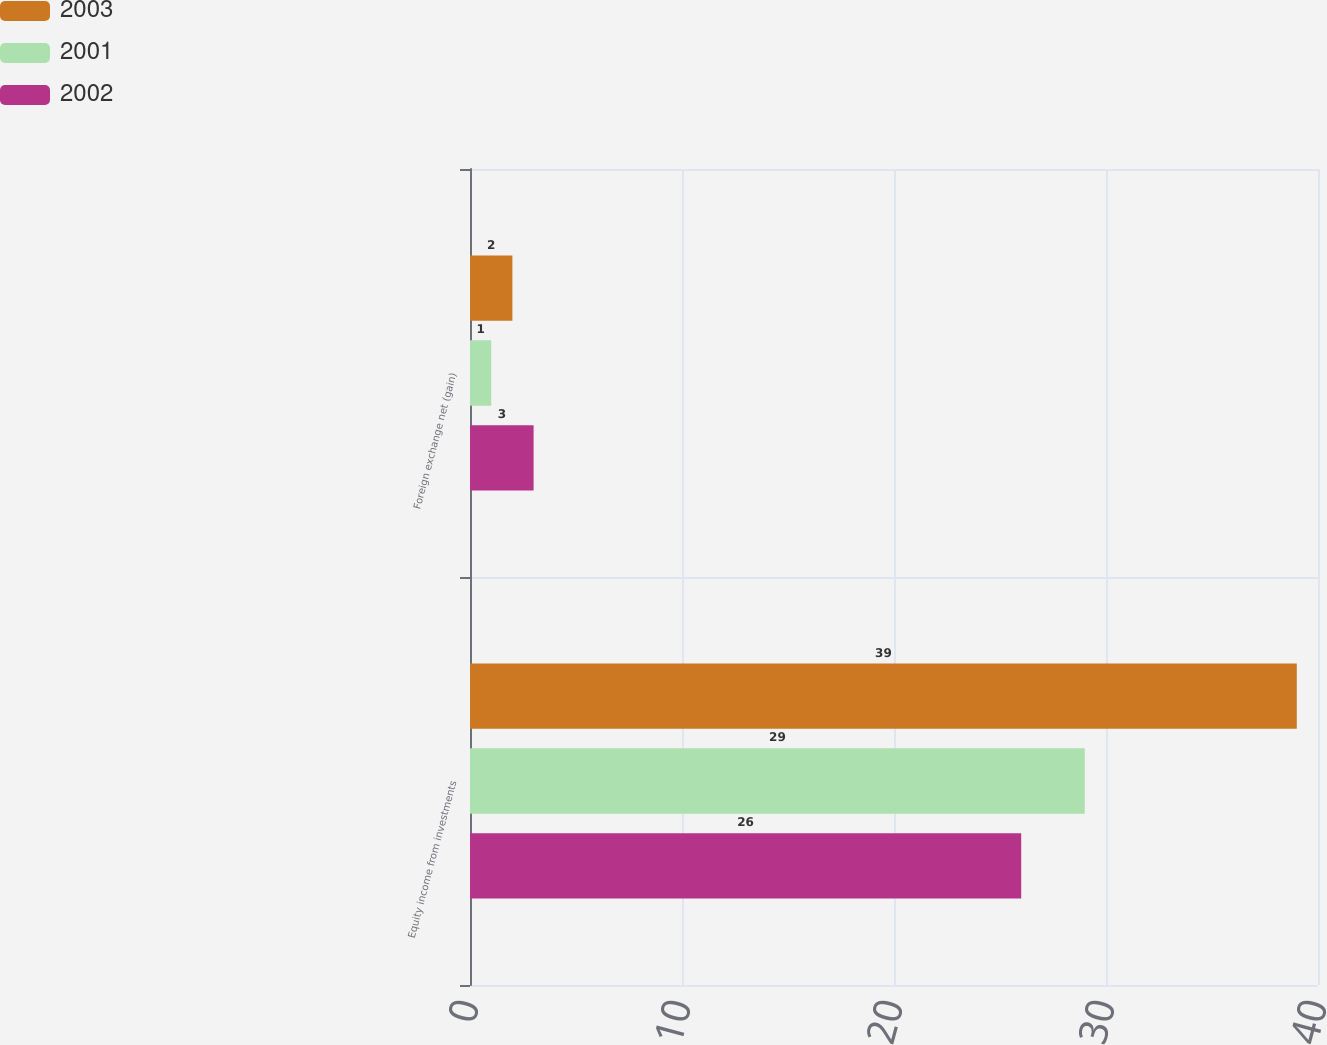<chart> <loc_0><loc_0><loc_500><loc_500><stacked_bar_chart><ecel><fcel>Equity income from investments<fcel>Foreign exchange net (gain)<nl><fcel>2003<fcel>39<fcel>2<nl><fcel>2001<fcel>29<fcel>1<nl><fcel>2002<fcel>26<fcel>3<nl></chart> 